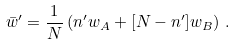<formula> <loc_0><loc_0><loc_500><loc_500>\bar { w } ^ { \prime } = \frac { 1 } { N } \left ( n ^ { \prime } w _ { A } + [ N - n ^ { \prime } ] w _ { B } \right ) \, .</formula> 